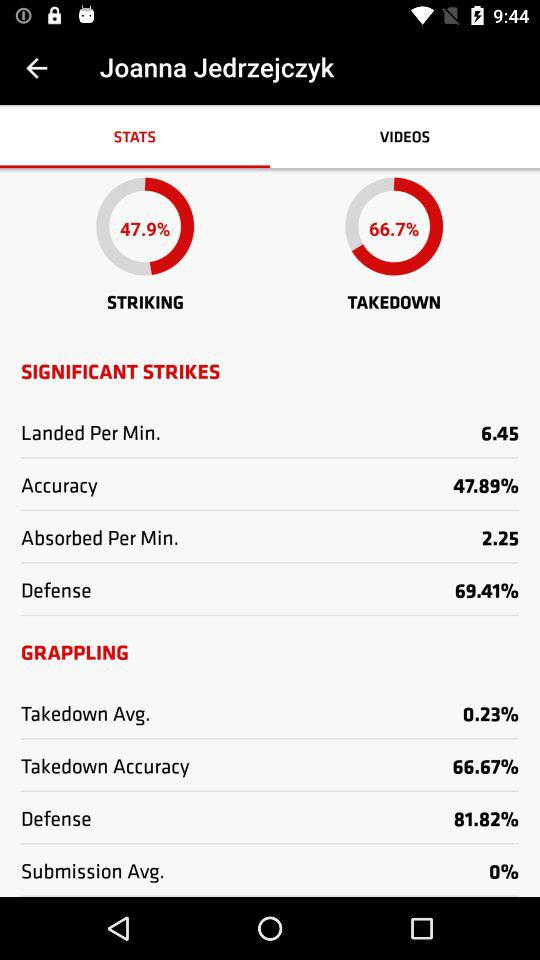How much is the submission average? The submission average is 0%. 